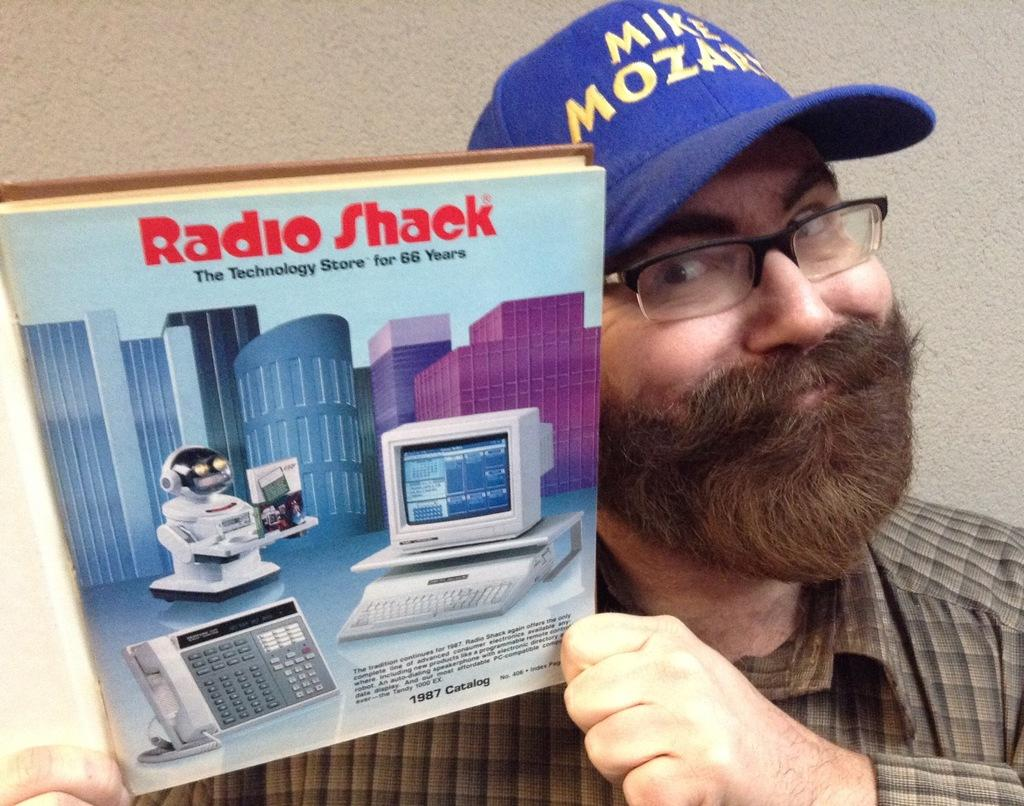Who or what is the main subject in the image? There is a person in the image. What is the person holding in the image? The person is holding a book. Where is the person and the book located in the image? The person and the book are in the center of the image. What type of current can be seen flowing through the book in the image? There is no current flowing through the book in the image; it is a physical book being held by a person. 